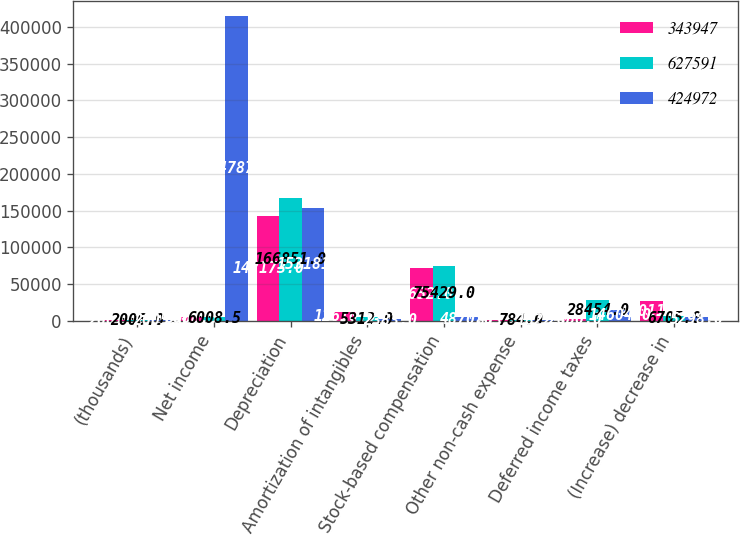Convert chart. <chart><loc_0><loc_0><loc_500><loc_500><stacked_bar_chart><ecel><fcel>(thousands)<fcel>Net income<fcel>Depreciation<fcel>Amortization of intangibles<fcel>Stock-based compensation<fcel>Other non-cash expense<fcel>Deferred income taxes<fcel>(Increase) decrease in<nl><fcel>343947<fcel>2007<fcel>6008.5<fcel>142173<fcel>12610<fcel>72652<fcel>853<fcel>2850<fcel>27011<nl><fcel>627591<fcel>2006<fcel>6008.5<fcel>166851<fcel>5312<fcel>75429<fcel>784<fcel>28454<fcel>6705<nl><fcel>424972<fcel>2005<fcel>414787<fcel>153181<fcel>2383<fcel>4870<fcel>1822<fcel>14604<fcel>5298<nl></chart> 